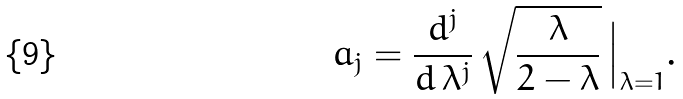<formula> <loc_0><loc_0><loc_500><loc_500>a _ { j } = \frac { d ^ { j } } { d \, \lambda ^ { j } } \, \sqrt { \frac { \lambda } { 2 - \lambda } } \, \Big { | } _ { \lambda = 1 } .</formula> 